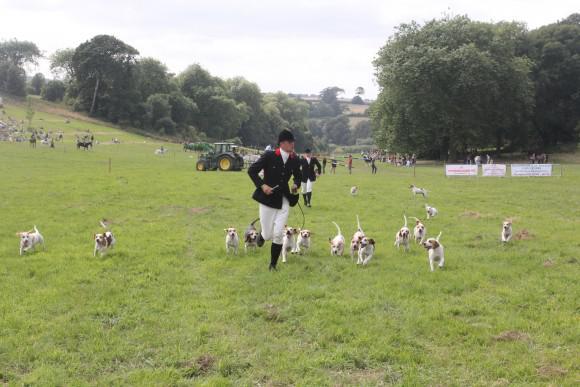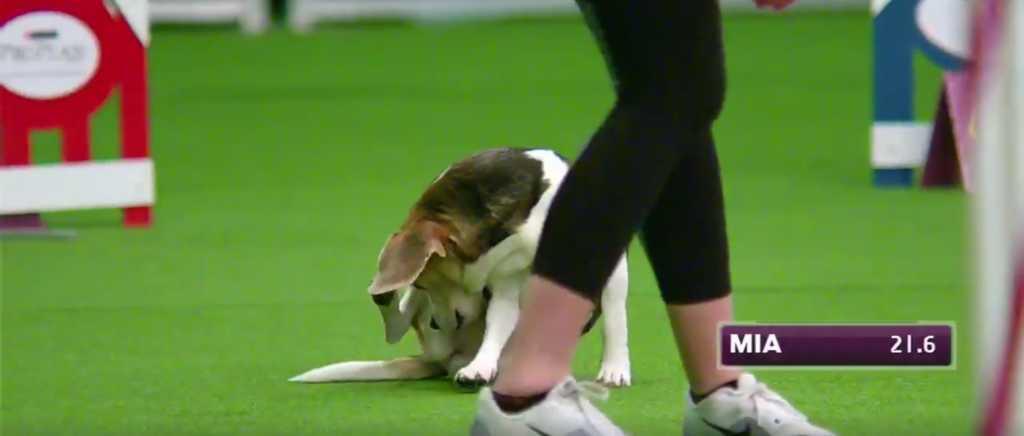The first image is the image on the left, the second image is the image on the right. Analyze the images presented: Is the assertion "One image contains a single Beagle and a girl in a purple shirt on an agility course." valid? Answer yes or no. No. 